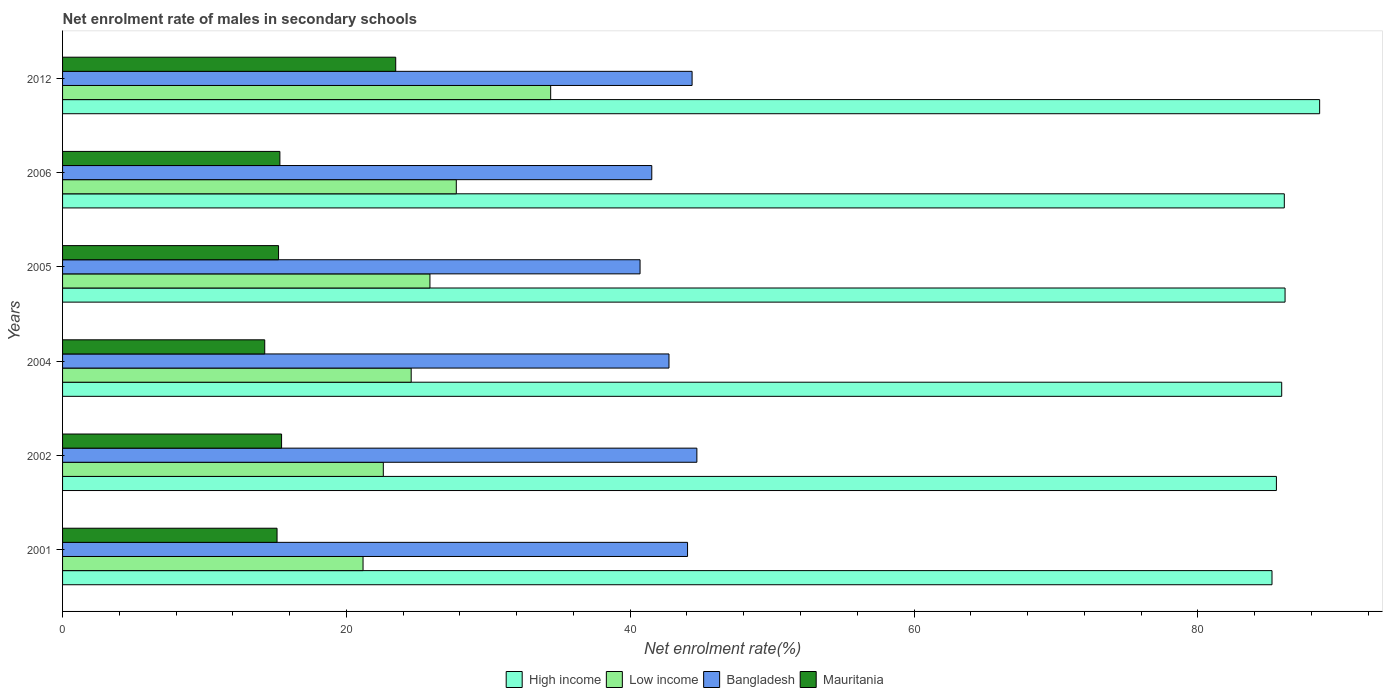How many bars are there on the 4th tick from the top?
Keep it short and to the point. 4. How many bars are there on the 1st tick from the bottom?
Offer a terse response. 4. What is the label of the 6th group of bars from the top?
Provide a short and direct response. 2001. What is the net enrolment rate of males in secondary schools in Bangladesh in 2002?
Your answer should be very brief. 44.7. Across all years, what is the maximum net enrolment rate of males in secondary schools in Low income?
Your answer should be compact. 34.4. Across all years, what is the minimum net enrolment rate of males in secondary schools in High income?
Give a very brief answer. 85.23. In which year was the net enrolment rate of males in secondary schools in High income maximum?
Keep it short and to the point. 2012. In which year was the net enrolment rate of males in secondary schools in High income minimum?
Offer a terse response. 2001. What is the total net enrolment rate of males in secondary schools in Bangladesh in the graph?
Provide a succinct answer. 258.05. What is the difference between the net enrolment rate of males in secondary schools in Bangladesh in 2001 and that in 2006?
Make the answer very short. 2.52. What is the difference between the net enrolment rate of males in secondary schools in Bangladesh in 2004 and the net enrolment rate of males in secondary schools in Mauritania in 2005?
Offer a very short reply. 27.51. What is the average net enrolment rate of males in secondary schools in High income per year?
Provide a short and direct response. 86.25. In the year 2005, what is the difference between the net enrolment rate of males in secondary schools in Low income and net enrolment rate of males in secondary schools in High income?
Your response must be concise. -60.26. What is the ratio of the net enrolment rate of males in secondary schools in Mauritania in 2001 to that in 2005?
Your answer should be very brief. 0.99. What is the difference between the highest and the second highest net enrolment rate of males in secondary schools in Low income?
Your response must be concise. 6.65. What is the difference between the highest and the lowest net enrolment rate of males in secondary schools in Bangladesh?
Your response must be concise. 4. In how many years, is the net enrolment rate of males in secondary schools in Bangladesh greater than the average net enrolment rate of males in secondary schools in Bangladesh taken over all years?
Offer a terse response. 3. What does the 1st bar from the top in 2006 represents?
Provide a short and direct response. Mauritania. Is it the case that in every year, the sum of the net enrolment rate of males in secondary schools in Bangladesh and net enrolment rate of males in secondary schools in Low income is greater than the net enrolment rate of males in secondary schools in Mauritania?
Make the answer very short. Yes. Are all the bars in the graph horizontal?
Your response must be concise. Yes. What is the difference between two consecutive major ticks on the X-axis?
Offer a terse response. 20. What is the title of the graph?
Your answer should be compact. Net enrolment rate of males in secondary schools. What is the label or title of the X-axis?
Your answer should be very brief. Net enrolment rate(%). What is the Net enrolment rate(%) in High income in 2001?
Ensure brevity in your answer.  85.23. What is the Net enrolment rate(%) of Low income in 2001?
Offer a terse response. 21.17. What is the Net enrolment rate(%) of Bangladesh in 2001?
Provide a succinct answer. 44.04. What is the Net enrolment rate(%) of Mauritania in 2001?
Keep it short and to the point. 15.11. What is the Net enrolment rate(%) of High income in 2002?
Your answer should be compact. 85.54. What is the Net enrolment rate(%) of Low income in 2002?
Offer a very short reply. 22.6. What is the Net enrolment rate(%) in Bangladesh in 2002?
Provide a short and direct response. 44.7. What is the Net enrolment rate(%) in Mauritania in 2002?
Give a very brief answer. 15.43. What is the Net enrolment rate(%) in High income in 2004?
Ensure brevity in your answer.  85.91. What is the Net enrolment rate(%) of Low income in 2004?
Make the answer very short. 24.57. What is the Net enrolment rate(%) of Bangladesh in 2004?
Provide a succinct answer. 42.73. What is the Net enrolment rate(%) in Mauritania in 2004?
Your answer should be compact. 14.25. What is the Net enrolment rate(%) in High income in 2005?
Offer a terse response. 86.15. What is the Net enrolment rate(%) in Low income in 2005?
Ensure brevity in your answer.  25.89. What is the Net enrolment rate(%) in Bangladesh in 2005?
Provide a short and direct response. 40.69. What is the Net enrolment rate(%) in Mauritania in 2005?
Offer a very short reply. 15.22. What is the Net enrolment rate(%) of High income in 2006?
Keep it short and to the point. 86.09. What is the Net enrolment rate(%) of Low income in 2006?
Offer a terse response. 27.75. What is the Net enrolment rate(%) in Bangladesh in 2006?
Offer a terse response. 41.52. What is the Net enrolment rate(%) in Mauritania in 2006?
Your answer should be very brief. 15.31. What is the Net enrolment rate(%) in High income in 2012?
Ensure brevity in your answer.  88.58. What is the Net enrolment rate(%) of Low income in 2012?
Your answer should be compact. 34.4. What is the Net enrolment rate(%) in Bangladesh in 2012?
Give a very brief answer. 44.36. What is the Net enrolment rate(%) in Mauritania in 2012?
Give a very brief answer. 23.48. Across all years, what is the maximum Net enrolment rate(%) in High income?
Make the answer very short. 88.58. Across all years, what is the maximum Net enrolment rate(%) in Low income?
Your answer should be compact. 34.4. Across all years, what is the maximum Net enrolment rate(%) in Bangladesh?
Make the answer very short. 44.7. Across all years, what is the maximum Net enrolment rate(%) in Mauritania?
Your answer should be compact. 23.48. Across all years, what is the minimum Net enrolment rate(%) in High income?
Provide a succinct answer. 85.23. Across all years, what is the minimum Net enrolment rate(%) of Low income?
Keep it short and to the point. 21.17. Across all years, what is the minimum Net enrolment rate(%) in Bangladesh?
Your answer should be very brief. 40.69. Across all years, what is the minimum Net enrolment rate(%) in Mauritania?
Give a very brief answer. 14.25. What is the total Net enrolment rate(%) of High income in the graph?
Your answer should be very brief. 517.5. What is the total Net enrolment rate(%) in Low income in the graph?
Give a very brief answer. 156.37. What is the total Net enrolment rate(%) in Bangladesh in the graph?
Keep it short and to the point. 258.05. What is the total Net enrolment rate(%) in Mauritania in the graph?
Your answer should be very brief. 98.8. What is the difference between the Net enrolment rate(%) of High income in 2001 and that in 2002?
Make the answer very short. -0.31. What is the difference between the Net enrolment rate(%) of Low income in 2001 and that in 2002?
Ensure brevity in your answer.  -1.43. What is the difference between the Net enrolment rate(%) of Bangladesh in 2001 and that in 2002?
Your answer should be very brief. -0.66. What is the difference between the Net enrolment rate(%) in Mauritania in 2001 and that in 2002?
Your response must be concise. -0.32. What is the difference between the Net enrolment rate(%) in High income in 2001 and that in 2004?
Your response must be concise. -0.68. What is the difference between the Net enrolment rate(%) in Low income in 2001 and that in 2004?
Your response must be concise. -3.39. What is the difference between the Net enrolment rate(%) in Bangladesh in 2001 and that in 2004?
Provide a succinct answer. 1.31. What is the difference between the Net enrolment rate(%) in Mauritania in 2001 and that in 2004?
Give a very brief answer. 0.87. What is the difference between the Net enrolment rate(%) in High income in 2001 and that in 2005?
Keep it short and to the point. -0.92. What is the difference between the Net enrolment rate(%) in Low income in 2001 and that in 2005?
Your answer should be compact. -4.71. What is the difference between the Net enrolment rate(%) in Bangladesh in 2001 and that in 2005?
Give a very brief answer. 3.35. What is the difference between the Net enrolment rate(%) in Mauritania in 2001 and that in 2005?
Give a very brief answer. -0.1. What is the difference between the Net enrolment rate(%) of High income in 2001 and that in 2006?
Provide a succinct answer. -0.87. What is the difference between the Net enrolment rate(%) of Low income in 2001 and that in 2006?
Give a very brief answer. -6.57. What is the difference between the Net enrolment rate(%) of Bangladesh in 2001 and that in 2006?
Offer a very short reply. 2.52. What is the difference between the Net enrolment rate(%) in Mauritania in 2001 and that in 2006?
Your answer should be very brief. -0.2. What is the difference between the Net enrolment rate(%) of High income in 2001 and that in 2012?
Your answer should be very brief. -3.36. What is the difference between the Net enrolment rate(%) in Low income in 2001 and that in 2012?
Your answer should be very brief. -13.22. What is the difference between the Net enrolment rate(%) of Bangladesh in 2001 and that in 2012?
Provide a short and direct response. -0.32. What is the difference between the Net enrolment rate(%) of Mauritania in 2001 and that in 2012?
Provide a short and direct response. -8.36. What is the difference between the Net enrolment rate(%) in High income in 2002 and that in 2004?
Your response must be concise. -0.37. What is the difference between the Net enrolment rate(%) in Low income in 2002 and that in 2004?
Your response must be concise. -1.96. What is the difference between the Net enrolment rate(%) of Bangladesh in 2002 and that in 2004?
Provide a succinct answer. 1.97. What is the difference between the Net enrolment rate(%) in Mauritania in 2002 and that in 2004?
Provide a short and direct response. 1.19. What is the difference between the Net enrolment rate(%) in High income in 2002 and that in 2005?
Provide a short and direct response. -0.61. What is the difference between the Net enrolment rate(%) in Low income in 2002 and that in 2005?
Offer a terse response. -3.29. What is the difference between the Net enrolment rate(%) of Bangladesh in 2002 and that in 2005?
Give a very brief answer. 4. What is the difference between the Net enrolment rate(%) in Mauritania in 2002 and that in 2005?
Provide a short and direct response. 0.21. What is the difference between the Net enrolment rate(%) in High income in 2002 and that in 2006?
Provide a succinct answer. -0.56. What is the difference between the Net enrolment rate(%) of Low income in 2002 and that in 2006?
Keep it short and to the point. -5.14. What is the difference between the Net enrolment rate(%) of Bangladesh in 2002 and that in 2006?
Provide a short and direct response. 3.18. What is the difference between the Net enrolment rate(%) of Mauritania in 2002 and that in 2006?
Make the answer very short. 0.12. What is the difference between the Net enrolment rate(%) in High income in 2002 and that in 2012?
Offer a very short reply. -3.05. What is the difference between the Net enrolment rate(%) of Low income in 2002 and that in 2012?
Provide a short and direct response. -11.79. What is the difference between the Net enrolment rate(%) in Bangladesh in 2002 and that in 2012?
Your answer should be very brief. 0.34. What is the difference between the Net enrolment rate(%) of Mauritania in 2002 and that in 2012?
Ensure brevity in your answer.  -8.04. What is the difference between the Net enrolment rate(%) of High income in 2004 and that in 2005?
Provide a succinct answer. -0.24. What is the difference between the Net enrolment rate(%) of Low income in 2004 and that in 2005?
Keep it short and to the point. -1.32. What is the difference between the Net enrolment rate(%) in Bangladesh in 2004 and that in 2005?
Your response must be concise. 2.04. What is the difference between the Net enrolment rate(%) in Mauritania in 2004 and that in 2005?
Offer a very short reply. -0.97. What is the difference between the Net enrolment rate(%) in High income in 2004 and that in 2006?
Make the answer very short. -0.18. What is the difference between the Net enrolment rate(%) in Low income in 2004 and that in 2006?
Your response must be concise. -3.18. What is the difference between the Net enrolment rate(%) in Bangladesh in 2004 and that in 2006?
Your response must be concise. 1.21. What is the difference between the Net enrolment rate(%) of Mauritania in 2004 and that in 2006?
Offer a terse response. -1.07. What is the difference between the Net enrolment rate(%) of High income in 2004 and that in 2012?
Provide a short and direct response. -2.67. What is the difference between the Net enrolment rate(%) in Low income in 2004 and that in 2012?
Offer a terse response. -9.83. What is the difference between the Net enrolment rate(%) in Bangladesh in 2004 and that in 2012?
Offer a terse response. -1.63. What is the difference between the Net enrolment rate(%) in Mauritania in 2004 and that in 2012?
Keep it short and to the point. -9.23. What is the difference between the Net enrolment rate(%) of High income in 2005 and that in 2006?
Provide a short and direct response. 0.05. What is the difference between the Net enrolment rate(%) of Low income in 2005 and that in 2006?
Give a very brief answer. -1.86. What is the difference between the Net enrolment rate(%) in Bangladesh in 2005 and that in 2006?
Your response must be concise. -0.83. What is the difference between the Net enrolment rate(%) of Mauritania in 2005 and that in 2006?
Your response must be concise. -0.1. What is the difference between the Net enrolment rate(%) of High income in 2005 and that in 2012?
Give a very brief answer. -2.44. What is the difference between the Net enrolment rate(%) of Low income in 2005 and that in 2012?
Offer a very short reply. -8.51. What is the difference between the Net enrolment rate(%) in Bangladesh in 2005 and that in 2012?
Offer a very short reply. -3.67. What is the difference between the Net enrolment rate(%) in Mauritania in 2005 and that in 2012?
Offer a very short reply. -8.26. What is the difference between the Net enrolment rate(%) of High income in 2006 and that in 2012?
Offer a very short reply. -2.49. What is the difference between the Net enrolment rate(%) in Low income in 2006 and that in 2012?
Give a very brief answer. -6.65. What is the difference between the Net enrolment rate(%) of Bangladesh in 2006 and that in 2012?
Keep it short and to the point. -2.84. What is the difference between the Net enrolment rate(%) in Mauritania in 2006 and that in 2012?
Offer a very short reply. -8.16. What is the difference between the Net enrolment rate(%) of High income in 2001 and the Net enrolment rate(%) of Low income in 2002?
Your answer should be very brief. 62.62. What is the difference between the Net enrolment rate(%) of High income in 2001 and the Net enrolment rate(%) of Bangladesh in 2002?
Your answer should be compact. 40.53. What is the difference between the Net enrolment rate(%) in High income in 2001 and the Net enrolment rate(%) in Mauritania in 2002?
Offer a terse response. 69.79. What is the difference between the Net enrolment rate(%) of Low income in 2001 and the Net enrolment rate(%) of Bangladesh in 2002?
Your answer should be very brief. -23.52. What is the difference between the Net enrolment rate(%) in Low income in 2001 and the Net enrolment rate(%) in Mauritania in 2002?
Your answer should be compact. 5.74. What is the difference between the Net enrolment rate(%) in Bangladesh in 2001 and the Net enrolment rate(%) in Mauritania in 2002?
Your response must be concise. 28.61. What is the difference between the Net enrolment rate(%) of High income in 2001 and the Net enrolment rate(%) of Low income in 2004?
Your answer should be compact. 60.66. What is the difference between the Net enrolment rate(%) in High income in 2001 and the Net enrolment rate(%) in Bangladesh in 2004?
Offer a terse response. 42.49. What is the difference between the Net enrolment rate(%) in High income in 2001 and the Net enrolment rate(%) in Mauritania in 2004?
Keep it short and to the point. 70.98. What is the difference between the Net enrolment rate(%) of Low income in 2001 and the Net enrolment rate(%) of Bangladesh in 2004?
Make the answer very short. -21.56. What is the difference between the Net enrolment rate(%) of Low income in 2001 and the Net enrolment rate(%) of Mauritania in 2004?
Your response must be concise. 6.93. What is the difference between the Net enrolment rate(%) in Bangladesh in 2001 and the Net enrolment rate(%) in Mauritania in 2004?
Offer a terse response. 29.79. What is the difference between the Net enrolment rate(%) of High income in 2001 and the Net enrolment rate(%) of Low income in 2005?
Make the answer very short. 59.34. What is the difference between the Net enrolment rate(%) of High income in 2001 and the Net enrolment rate(%) of Bangladesh in 2005?
Your response must be concise. 44.53. What is the difference between the Net enrolment rate(%) of High income in 2001 and the Net enrolment rate(%) of Mauritania in 2005?
Your response must be concise. 70.01. What is the difference between the Net enrolment rate(%) of Low income in 2001 and the Net enrolment rate(%) of Bangladesh in 2005?
Your answer should be compact. -19.52. What is the difference between the Net enrolment rate(%) of Low income in 2001 and the Net enrolment rate(%) of Mauritania in 2005?
Give a very brief answer. 5.95. What is the difference between the Net enrolment rate(%) of Bangladesh in 2001 and the Net enrolment rate(%) of Mauritania in 2005?
Provide a succinct answer. 28.82. What is the difference between the Net enrolment rate(%) of High income in 2001 and the Net enrolment rate(%) of Low income in 2006?
Your answer should be very brief. 57.48. What is the difference between the Net enrolment rate(%) in High income in 2001 and the Net enrolment rate(%) in Bangladesh in 2006?
Give a very brief answer. 43.71. What is the difference between the Net enrolment rate(%) in High income in 2001 and the Net enrolment rate(%) in Mauritania in 2006?
Offer a terse response. 69.91. What is the difference between the Net enrolment rate(%) in Low income in 2001 and the Net enrolment rate(%) in Bangladesh in 2006?
Your answer should be very brief. -20.35. What is the difference between the Net enrolment rate(%) in Low income in 2001 and the Net enrolment rate(%) in Mauritania in 2006?
Your answer should be very brief. 5.86. What is the difference between the Net enrolment rate(%) of Bangladesh in 2001 and the Net enrolment rate(%) of Mauritania in 2006?
Offer a terse response. 28.73. What is the difference between the Net enrolment rate(%) of High income in 2001 and the Net enrolment rate(%) of Low income in 2012?
Your response must be concise. 50.83. What is the difference between the Net enrolment rate(%) of High income in 2001 and the Net enrolment rate(%) of Bangladesh in 2012?
Give a very brief answer. 40.86. What is the difference between the Net enrolment rate(%) in High income in 2001 and the Net enrolment rate(%) in Mauritania in 2012?
Give a very brief answer. 61.75. What is the difference between the Net enrolment rate(%) in Low income in 2001 and the Net enrolment rate(%) in Bangladesh in 2012?
Your answer should be compact. -23.19. What is the difference between the Net enrolment rate(%) in Low income in 2001 and the Net enrolment rate(%) in Mauritania in 2012?
Give a very brief answer. -2.3. What is the difference between the Net enrolment rate(%) of Bangladesh in 2001 and the Net enrolment rate(%) of Mauritania in 2012?
Your response must be concise. 20.56. What is the difference between the Net enrolment rate(%) in High income in 2002 and the Net enrolment rate(%) in Low income in 2004?
Make the answer very short. 60.97. What is the difference between the Net enrolment rate(%) in High income in 2002 and the Net enrolment rate(%) in Bangladesh in 2004?
Ensure brevity in your answer.  42.8. What is the difference between the Net enrolment rate(%) in High income in 2002 and the Net enrolment rate(%) in Mauritania in 2004?
Offer a terse response. 71.29. What is the difference between the Net enrolment rate(%) of Low income in 2002 and the Net enrolment rate(%) of Bangladesh in 2004?
Offer a very short reply. -20.13. What is the difference between the Net enrolment rate(%) of Low income in 2002 and the Net enrolment rate(%) of Mauritania in 2004?
Offer a very short reply. 8.36. What is the difference between the Net enrolment rate(%) of Bangladesh in 2002 and the Net enrolment rate(%) of Mauritania in 2004?
Your response must be concise. 30.45. What is the difference between the Net enrolment rate(%) in High income in 2002 and the Net enrolment rate(%) in Low income in 2005?
Keep it short and to the point. 59.65. What is the difference between the Net enrolment rate(%) in High income in 2002 and the Net enrolment rate(%) in Bangladesh in 2005?
Offer a very short reply. 44.84. What is the difference between the Net enrolment rate(%) in High income in 2002 and the Net enrolment rate(%) in Mauritania in 2005?
Offer a very short reply. 70.32. What is the difference between the Net enrolment rate(%) of Low income in 2002 and the Net enrolment rate(%) of Bangladesh in 2005?
Offer a terse response. -18.09. What is the difference between the Net enrolment rate(%) in Low income in 2002 and the Net enrolment rate(%) in Mauritania in 2005?
Ensure brevity in your answer.  7.38. What is the difference between the Net enrolment rate(%) in Bangladesh in 2002 and the Net enrolment rate(%) in Mauritania in 2005?
Ensure brevity in your answer.  29.48. What is the difference between the Net enrolment rate(%) in High income in 2002 and the Net enrolment rate(%) in Low income in 2006?
Provide a succinct answer. 57.79. What is the difference between the Net enrolment rate(%) of High income in 2002 and the Net enrolment rate(%) of Bangladesh in 2006?
Offer a terse response. 44.02. What is the difference between the Net enrolment rate(%) of High income in 2002 and the Net enrolment rate(%) of Mauritania in 2006?
Your answer should be very brief. 70.22. What is the difference between the Net enrolment rate(%) in Low income in 2002 and the Net enrolment rate(%) in Bangladesh in 2006?
Offer a terse response. -18.92. What is the difference between the Net enrolment rate(%) in Low income in 2002 and the Net enrolment rate(%) in Mauritania in 2006?
Provide a succinct answer. 7.29. What is the difference between the Net enrolment rate(%) in Bangladesh in 2002 and the Net enrolment rate(%) in Mauritania in 2006?
Your answer should be very brief. 29.38. What is the difference between the Net enrolment rate(%) of High income in 2002 and the Net enrolment rate(%) of Low income in 2012?
Provide a succinct answer. 51.14. What is the difference between the Net enrolment rate(%) in High income in 2002 and the Net enrolment rate(%) in Bangladesh in 2012?
Ensure brevity in your answer.  41.17. What is the difference between the Net enrolment rate(%) in High income in 2002 and the Net enrolment rate(%) in Mauritania in 2012?
Ensure brevity in your answer.  62.06. What is the difference between the Net enrolment rate(%) in Low income in 2002 and the Net enrolment rate(%) in Bangladesh in 2012?
Ensure brevity in your answer.  -21.76. What is the difference between the Net enrolment rate(%) of Low income in 2002 and the Net enrolment rate(%) of Mauritania in 2012?
Your response must be concise. -0.87. What is the difference between the Net enrolment rate(%) of Bangladesh in 2002 and the Net enrolment rate(%) of Mauritania in 2012?
Ensure brevity in your answer.  21.22. What is the difference between the Net enrolment rate(%) of High income in 2004 and the Net enrolment rate(%) of Low income in 2005?
Make the answer very short. 60.02. What is the difference between the Net enrolment rate(%) of High income in 2004 and the Net enrolment rate(%) of Bangladesh in 2005?
Your answer should be compact. 45.22. What is the difference between the Net enrolment rate(%) in High income in 2004 and the Net enrolment rate(%) in Mauritania in 2005?
Provide a succinct answer. 70.69. What is the difference between the Net enrolment rate(%) in Low income in 2004 and the Net enrolment rate(%) in Bangladesh in 2005?
Your response must be concise. -16.13. What is the difference between the Net enrolment rate(%) of Low income in 2004 and the Net enrolment rate(%) of Mauritania in 2005?
Your answer should be compact. 9.35. What is the difference between the Net enrolment rate(%) of Bangladesh in 2004 and the Net enrolment rate(%) of Mauritania in 2005?
Provide a short and direct response. 27.51. What is the difference between the Net enrolment rate(%) in High income in 2004 and the Net enrolment rate(%) in Low income in 2006?
Ensure brevity in your answer.  58.16. What is the difference between the Net enrolment rate(%) of High income in 2004 and the Net enrolment rate(%) of Bangladesh in 2006?
Your response must be concise. 44.39. What is the difference between the Net enrolment rate(%) of High income in 2004 and the Net enrolment rate(%) of Mauritania in 2006?
Make the answer very short. 70.6. What is the difference between the Net enrolment rate(%) of Low income in 2004 and the Net enrolment rate(%) of Bangladesh in 2006?
Offer a very short reply. -16.95. What is the difference between the Net enrolment rate(%) in Low income in 2004 and the Net enrolment rate(%) in Mauritania in 2006?
Your response must be concise. 9.25. What is the difference between the Net enrolment rate(%) of Bangladesh in 2004 and the Net enrolment rate(%) of Mauritania in 2006?
Offer a terse response. 27.42. What is the difference between the Net enrolment rate(%) of High income in 2004 and the Net enrolment rate(%) of Low income in 2012?
Offer a terse response. 51.51. What is the difference between the Net enrolment rate(%) of High income in 2004 and the Net enrolment rate(%) of Bangladesh in 2012?
Your answer should be very brief. 41.55. What is the difference between the Net enrolment rate(%) in High income in 2004 and the Net enrolment rate(%) in Mauritania in 2012?
Keep it short and to the point. 62.43. What is the difference between the Net enrolment rate(%) in Low income in 2004 and the Net enrolment rate(%) in Bangladesh in 2012?
Offer a very short reply. -19.79. What is the difference between the Net enrolment rate(%) in Low income in 2004 and the Net enrolment rate(%) in Mauritania in 2012?
Give a very brief answer. 1.09. What is the difference between the Net enrolment rate(%) in Bangladesh in 2004 and the Net enrolment rate(%) in Mauritania in 2012?
Keep it short and to the point. 19.26. What is the difference between the Net enrolment rate(%) in High income in 2005 and the Net enrolment rate(%) in Low income in 2006?
Give a very brief answer. 58.4. What is the difference between the Net enrolment rate(%) of High income in 2005 and the Net enrolment rate(%) of Bangladesh in 2006?
Your response must be concise. 44.63. What is the difference between the Net enrolment rate(%) of High income in 2005 and the Net enrolment rate(%) of Mauritania in 2006?
Your answer should be compact. 70.83. What is the difference between the Net enrolment rate(%) in Low income in 2005 and the Net enrolment rate(%) in Bangladesh in 2006?
Your response must be concise. -15.63. What is the difference between the Net enrolment rate(%) in Low income in 2005 and the Net enrolment rate(%) in Mauritania in 2006?
Your response must be concise. 10.57. What is the difference between the Net enrolment rate(%) in Bangladesh in 2005 and the Net enrolment rate(%) in Mauritania in 2006?
Your answer should be compact. 25.38. What is the difference between the Net enrolment rate(%) in High income in 2005 and the Net enrolment rate(%) in Low income in 2012?
Provide a succinct answer. 51.75. What is the difference between the Net enrolment rate(%) of High income in 2005 and the Net enrolment rate(%) of Bangladesh in 2012?
Offer a very short reply. 41.79. What is the difference between the Net enrolment rate(%) in High income in 2005 and the Net enrolment rate(%) in Mauritania in 2012?
Give a very brief answer. 62.67. What is the difference between the Net enrolment rate(%) in Low income in 2005 and the Net enrolment rate(%) in Bangladesh in 2012?
Provide a short and direct response. -18.47. What is the difference between the Net enrolment rate(%) of Low income in 2005 and the Net enrolment rate(%) of Mauritania in 2012?
Offer a terse response. 2.41. What is the difference between the Net enrolment rate(%) of Bangladesh in 2005 and the Net enrolment rate(%) of Mauritania in 2012?
Give a very brief answer. 17.22. What is the difference between the Net enrolment rate(%) of High income in 2006 and the Net enrolment rate(%) of Low income in 2012?
Your answer should be very brief. 51.7. What is the difference between the Net enrolment rate(%) in High income in 2006 and the Net enrolment rate(%) in Bangladesh in 2012?
Give a very brief answer. 41.73. What is the difference between the Net enrolment rate(%) in High income in 2006 and the Net enrolment rate(%) in Mauritania in 2012?
Your response must be concise. 62.62. What is the difference between the Net enrolment rate(%) of Low income in 2006 and the Net enrolment rate(%) of Bangladesh in 2012?
Provide a succinct answer. -16.62. What is the difference between the Net enrolment rate(%) in Low income in 2006 and the Net enrolment rate(%) in Mauritania in 2012?
Offer a very short reply. 4.27. What is the difference between the Net enrolment rate(%) in Bangladesh in 2006 and the Net enrolment rate(%) in Mauritania in 2012?
Offer a very short reply. 18.04. What is the average Net enrolment rate(%) in High income per year?
Give a very brief answer. 86.25. What is the average Net enrolment rate(%) in Low income per year?
Offer a terse response. 26.06. What is the average Net enrolment rate(%) of Bangladesh per year?
Offer a terse response. 43.01. What is the average Net enrolment rate(%) of Mauritania per year?
Keep it short and to the point. 16.47. In the year 2001, what is the difference between the Net enrolment rate(%) in High income and Net enrolment rate(%) in Low income?
Offer a very short reply. 64.05. In the year 2001, what is the difference between the Net enrolment rate(%) in High income and Net enrolment rate(%) in Bangladesh?
Keep it short and to the point. 41.19. In the year 2001, what is the difference between the Net enrolment rate(%) in High income and Net enrolment rate(%) in Mauritania?
Offer a very short reply. 70.11. In the year 2001, what is the difference between the Net enrolment rate(%) in Low income and Net enrolment rate(%) in Bangladesh?
Provide a succinct answer. -22.87. In the year 2001, what is the difference between the Net enrolment rate(%) in Low income and Net enrolment rate(%) in Mauritania?
Offer a terse response. 6.06. In the year 2001, what is the difference between the Net enrolment rate(%) of Bangladesh and Net enrolment rate(%) of Mauritania?
Make the answer very short. 28.93. In the year 2002, what is the difference between the Net enrolment rate(%) in High income and Net enrolment rate(%) in Low income?
Provide a short and direct response. 62.93. In the year 2002, what is the difference between the Net enrolment rate(%) of High income and Net enrolment rate(%) of Bangladesh?
Provide a succinct answer. 40.84. In the year 2002, what is the difference between the Net enrolment rate(%) in High income and Net enrolment rate(%) in Mauritania?
Keep it short and to the point. 70.1. In the year 2002, what is the difference between the Net enrolment rate(%) in Low income and Net enrolment rate(%) in Bangladesh?
Ensure brevity in your answer.  -22.1. In the year 2002, what is the difference between the Net enrolment rate(%) of Low income and Net enrolment rate(%) of Mauritania?
Provide a short and direct response. 7.17. In the year 2002, what is the difference between the Net enrolment rate(%) of Bangladesh and Net enrolment rate(%) of Mauritania?
Keep it short and to the point. 29.26. In the year 2004, what is the difference between the Net enrolment rate(%) of High income and Net enrolment rate(%) of Low income?
Provide a succinct answer. 61.34. In the year 2004, what is the difference between the Net enrolment rate(%) of High income and Net enrolment rate(%) of Bangladesh?
Your answer should be compact. 43.18. In the year 2004, what is the difference between the Net enrolment rate(%) of High income and Net enrolment rate(%) of Mauritania?
Provide a short and direct response. 71.66. In the year 2004, what is the difference between the Net enrolment rate(%) of Low income and Net enrolment rate(%) of Bangladesh?
Give a very brief answer. -18.17. In the year 2004, what is the difference between the Net enrolment rate(%) in Low income and Net enrolment rate(%) in Mauritania?
Keep it short and to the point. 10.32. In the year 2004, what is the difference between the Net enrolment rate(%) in Bangladesh and Net enrolment rate(%) in Mauritania?
Make the answer very short. 28.49. In the year 2005, what is the difference between the Net enrolment rate(%) of High income and Net enrolment rate(%) of Low income?
Keep it short and to the point. 60.26. In the year 2005, what is the difference between the Net enrolment rate(%) of High income and Net enrolment rate(%) of Bangladesh?
Ensure brevity in your answer.  45.45. In the year 2005, what is the difference between the Net enrolment rate(%) of High income and Net enrolment rate(%) of Mauritania?
Provide a short and direct response. 70.93. In the year 2005, what is the difference between the Net enrolment rate(%) of Low income and Net enrolment rate(%) of Bangladesh?
Your response must be concise. -14.81. In the year 2005, what is the difference between the Net enrolment rate(%) in Low income and Net enrolment rate(%) in Mauritania?
Give a very brief answer. 10.67. In the year 2005, what is the difference between the Net enrolment rate(%) in Bangladesh and Net enrolment rate(%) in Mauritania?
Keep it short and to the point. 25.48. In the year 2006, what is the difference between the Net enrolment rate(%) in High income and Net enrolment rate(%) in Low income?
Your response must be concise. 58.35. In the year 2006, what is the difference between the Net enrolment rate(%) in High income and Net enrolment rate(%) in Bangladesh?
Keep it short and to the point. 44.57. In the year 2006, what is the difference between the Net enrolment rate(%) of High income and Net enrolment rate(%) of Mauritania?
Make the answer very short. 70.78. In the year 2006, what is the difference between the Net enrolment rate(%) of Low income and Net enrolment rate(%) of Bangladesh?
Your answer should be very brief. -13.77. In the year 2006, what is the difference between the Net enrolment rate(%) of Low income and Net enrolment rate(%) of Mauritania?
Offer a terse response. 12.43. In the year 2006, what is the difference between the Net enrolment rate(%) in Bangladesh and Net enrolment rate(%) in Mauritania?
Offer a terse response. 26.21. In the year 2012, what is the difference between the Net enrolment rate(%) of High income and Net enrolment rate(%) of Low income?
Offer a very short reply. 54.19. In the year 2012, what is the difference between the Net enrolment rate(%) of High income and Net enrolment rate(%) of Bangladesh?
Make the answer very short. 44.22. In the year 2012, what is the difference between the Net enrolment rate(%) of High income and Net enrolment rate(%) of Mauritania?
Give a very brief answer. 65.11. In the year 2012, what is the difference between the Net enrolment rate(%) of Low income and Net enrolment rate(%) of Bangladesh?
Keep it short and to the point. -9.97. In the year 2012, what is the difference between the Net enrolment rate(%) of Low income and Net enrolment rate(%) of Mauritania?
Provide a short and direct response. 10.92. In the year 2012, what is the difference between the Net enrolment rate(%) in Bangladesh and Net enrolment rate(%) in Mauritania?
Provide a short and direct response. 20.88. What is the ratio of the Net enrolment rate(%) of High income in 2001 to that in 2002?
Provide a succinct answer. 1. What is the ratio of the Net enrolment rate(%) in Low income in 2001 to that in 2002?
Your answer should be very brief. 0.94. What is the ratio of the Net enrolment rate(%) of Bangladesh in 2001 to that in 2002?
Keep it short and to the point. 0.99. What is the ratio of the Net enrolment rate(%) of Mauritania in 2001 to that in 2002?
Give a very brief answer. 0.98. What is the ratio of the Net enrolment rate(%) in High income in 2001 to that in 2004?
Keep it short and to the point. 0.99. What is the ratio of the Net enrolment rate(%) of Low income in 2001 to that in 2004?
Ensure brevity in your answer.  0.86. What is the ratio of the Net enrolment rate(%) of Bangladesh in 2001 to that in 2004?
Offer a terse response. 1.03. What is the ratio of the Net enrolment rate(%) of Mauritania in 2001 to that in 2004?
Give a very brief answer. 1.06. What is the ratio of the Net enrolment rate(%) in High income in 2001 to that in 2005?
Provide a short and direct response. 0.99. What is the ratio of the Net enrolment rate(%) of Low income in 2001 to that in 2005?
Give a very brief answer. 0.82. What is the ratio of the Net enrolment rate(%) of Bangladesh in 2001 to that in 2005?
Give a very brief answer. 1.08. What is the ratio of the Net enrolment rate(%) in Mauritania in 2001 to that in 2005?
Give a very brief answer. 0.99. What is the ratio of the Net enrolment rate(%) in Low income in 2001 to that in 2006?
Provide a succinct answer. 0.76. What is the ratio of the Net enrolment rate(%) of Bangladesh in 2001 to that in 2006?
Your response must be concise. 1.06. What is the ratio of the Net enrolment rate(%) in Mauritania in 2001 to that in 2006?
Offer a terse response. 0.99. What is the ratio of the Net enrolment rate(%) in High income in 2001 to that in 2012?
Offer a terse response. 0.96. What is the ratio of the Net enrolment rate(%) in Low income in 2001 to that in 2012?
Your answer should be compact. 0.62. What is the ratio of the Net enrolment rate(%) of Bangladesh in 2001 to that in 2012?
Your response must be concise. 0.99. What is the ratio of the Net enrolment rate(%) of Mauritania in 2001 to that in 2012?
Give a very brief answer. 0.64. What is the ratio of the Net enrolment rate(%) in Low income in 2002 to that in 2004?
Offer a very short reply. 0.92. What is the ratio of the Net enrolment rate(%) of Bangladesh in 2002 to that in 2004?
Your answer should be very brief. 1.05. What is the ratio of the Net enrolment rate(%) in High income in 2002 to that in 2005?
Your answer should be very brief. 0.99. What is the ratio of the Net enrolment rate(%) in Low income in 2002 to that in 2005?
Give a very brief answer. 0.87. What is the ratio of the Net enrolment rate(%) of Bangladesh in 2002 to that in 2005?
Make the answer very short. 1.1. What is the ratio of the Net enrolment rate(%) in Mauritania in 2002 to that in 2005?
Make the answer very short. 1.01. What is the ratio of the Net enrolment rate(%) in High income in 2002 to that in 2006?
Ensure brevity in your answer.  0.99. What is the ratio of the Net enrolment rate(%) of Low income in 2002 to that in 2006?
Make the answer very short. 0.81. What is the ratio of the Net enrolment rate(%) of Bangladesh in 2002 to that in 2006?
Provide a short and direct response. 1.08. What is the ratio of the Net enrolment rate(%) in Mauritania in 2002 to that in 2006?
Your answer should be very brief. 1.01. What is the ratio of the Net enrolment rate(%) in High income in 2002 to that in 2012?
Make the answer very short. 0.97. What is the ratio of the Net enrolment rate(%) of Low income in 2002 to that in 2012?
Your answer should be compact. 0.66. What is the ratio of the Net enrolment rate(%) of Bangladesh in 2002 to that in 2012?
Keep it short and to the point. 1.01. What is the ratio of the Net enrolment rate(%) in Mauritania in 2002 to that in 2012?
Your answer should be compact. 0.66. What is the ratio of the Net enrolment rate(%) of Low income in 2004 to that in 2005?
Ensure brevity in your answer.  0.95. What is the ratio of the Net enrolment rate(%) in Bangladesh in 2004 to that in 2005?
Provide a succinct answer. 1.05. What is the ratio of the Net enrolment rate(%) of Mauritania in 2004 to that in 2005?
Offer a terse response. 0.94. What is the ratio of the Net enrolment rate(%) of High income in 2004 to that in 2006?
Offer a very short reply. 1. What is the ratio of the Net enrolment rate(%) in Low income in 2004 to that in 2006?
Your answer should be compact. 0.89. What is the ratio of the Net enrolment rate(%) in Bangladesh in 2004 to that in 2006?
Offer a very short reply. 1.03. What is the ratio of the Net enrolment rate(%) in Mauritania in 2004 to that in 2006?
Your answer should be very brief. 0.93. What is the ratio of the Net enrolment rate(%) of High income in 2004 to that in 2012?
Your response must be concise. 0.97. What is the ratio of the Net enrolment rate(%) in Low income in 2004 to that in 2012?
Keep it short and to the point. 0.71. What is the ratio of the Net enrolment rate(%) of Bangladesh in 2004 to that in 2012?
Keep it short and to the point. 0.96. What is the ratio of the Net enrolment rate(%) of Mauritania in 2004 to that in 2012?
Give a very brief answer. 0.61. What is the ratio of the Net enrolment rate(%) of High income in 2005 to that in 2006?
Your answer should be very brief. 1. What is the ratio of the Net enrolment rate(%) of Low income in 2005 to that in 2006?
Provide a succinct answer. 0.93. What is the ratio of the Net enrolment rate(%) of Bangladesh in 2005 to that in 2006?
Keep it short and to the point. 0.98. What is the ratio of the Net enrolment rate(%) in High income in 2005 to that in 2012?
Your answer should be very brief. 0.97. What is the ratio of the Net enrolment rate(%) of Low income in 2005 to that in 2012?
Provide a short and direct response. 0.75. What is the ratio of the Net enrolment rate(%) in Bangladesh in 2005 to that in 2012?
Give a very brief answer. 0.92. What is the ratio of the Net enrolment rate(%) in Mauritania in 2005 to that in 2012?
Ensure brevity in your answer.  0.65. What is the ratio of the Net enrolment rate(%) of High income in 2006 to that in 2012?
Your response must be concise. 0.97. What is the ratio of the Net enrolment rate(%) of Low income in 2006 to that in 2012?
Ensure brevity in your answer.  0.81. What is the ratio of the Net enrolment rate(%) of Bangladesh in 2006 to that in 2012?
Provide a succinct answer. 0.94. What is the ratio of the Net enrolment rate(%) in Mauritania in 2006 to that in 2012?
Ensure brevity in your answer.  0.65. What is the difference between the highest and the second highest Net enrolment rate(%) in High income?
Provide a succinct answer. 2.44. What is the difference between the highest and the second highest Net enrolment rate(%) of Low income?
Offer a very short reply. 6.65. What is the difference between the highest and the second highest Net enrolment rate(%) in Bangladesh?
Your answer should be compact. 0.34. What is the difference between the highest and the second highest Net enrolment rate(%) of Mauritania?
Give a very brief answer. 8.04. What is the difference between the highest and the lowest Net enrolment rate(%) in High income?
Ensure brevity in your answer.  3.36. What is the difference between the highest and the lowest Net enrolment rate(%) in Low income?
Ensure brevity in your answer.  13.22. What is the difference between the highest and the lowest Net enrolment rate(%) in Bangladesh?
Your answer should be very brief. 4. What is the difference between the highest and the lowest Net enrolment rate(%) of Mauritania?
Offer a very short reply. 9.23. 